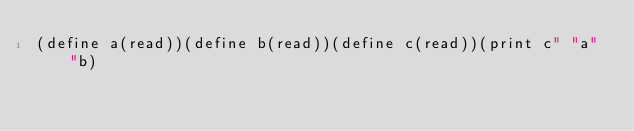<code> <loc_0><loc_0><loc_500><loc_500><_Scheme_>(define a(read))(define b(read))(define c(read))(print c" "a" "b)</code> 